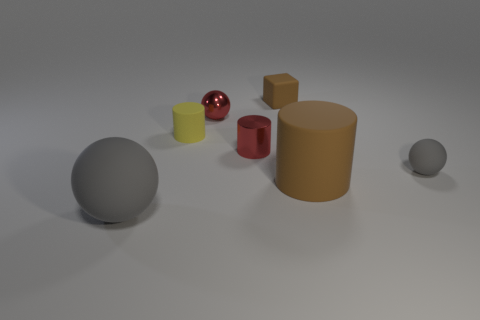Add 3 red shiny spheres. How many objects exist? 10 Subtract all cylinders. How many objects are left? 4 Subtract 1 yellow cylinders. How many objects are left? 6 Subtract all cyan matte blocks. Subtract all red things. How many objects are left? 5 Add 1 gray matte objects. How many gray matte objects are left? 3 Add 6 large rubber balls. How many large rubber balls exist? 7 